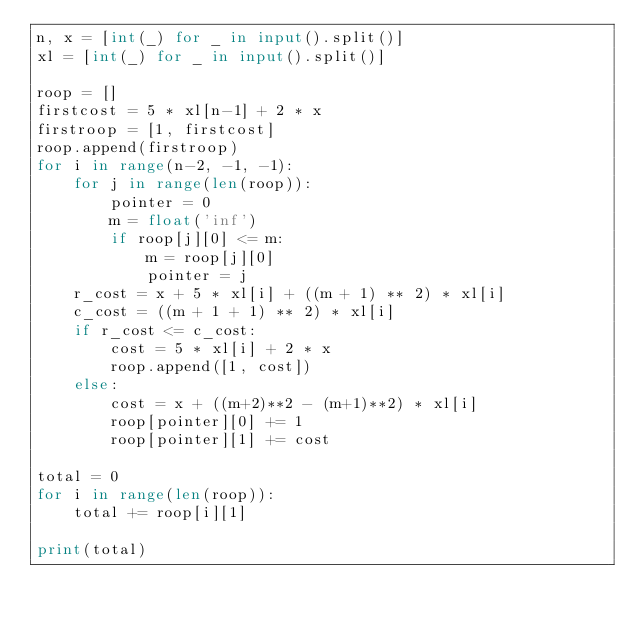<code> <loc_0><loc_0><loc_500><loc_500><_Python_>n, x = [int(_) for _ in input().split()]
xl = [int(_) for _ in input().split()]

roop = []
firstcost = 5 * xl[n-1] + 2 * x
firstroop = [1, firstcost]
roop.append(firstroop)
for i in range(n-2, -1, -1):
    for j in range(len(roop)):
        pointer = 0
        m = float('inf')
        if roop[j][0] <= m:
            m = roop[j][0]
            pointer = j
    r_cost = x + 5 * xl[i] + ((m + 1) ** 2) * xl[i]
    c_cost = ((m + 1 + 1) ** 2) * xl[i]
    if r_cost <= c_cost:
        cost = 5 * xl[i] + 2 * x
        roop.append([1, cost])
    else:
        cost = x + ((m+2)**2 - (m+1)**2) * xl[i]
        roop[pointer][0] += 1
        roop[pointer][1] += cost

total = 0
for i in range(len(roop)):
    total += roop[i][1]

print(total)</code> 